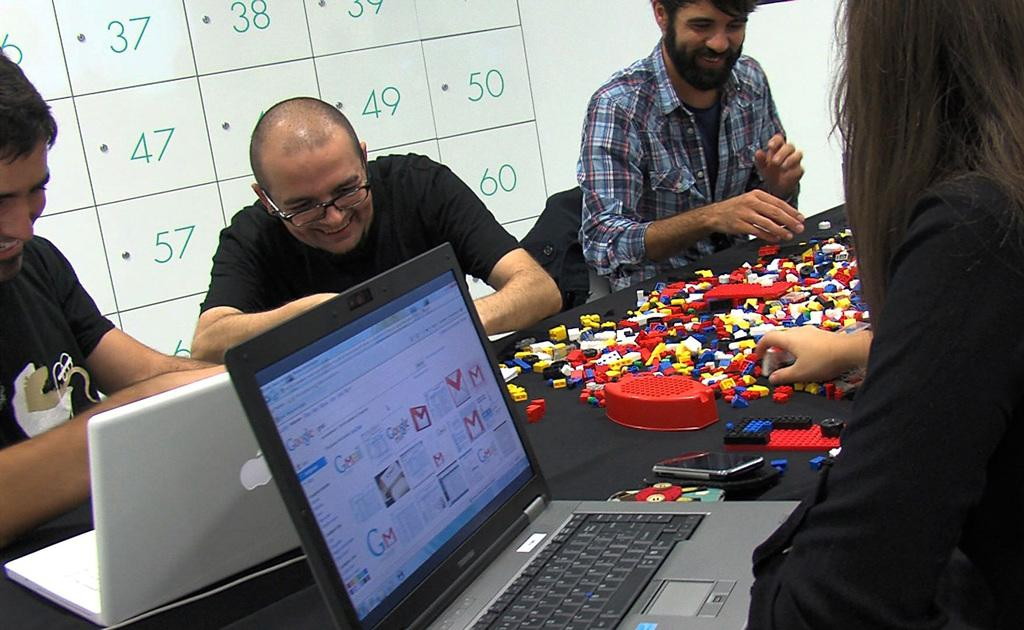<image>
Describe the image concisely. A computer checks google while other people play with legos. 